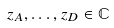Convert formula to latex. <formula><loc_0><loc_0><loc_500><loc_500>z _ { A } , \dots , z _ { D } \in \mathbb { C }</formula> 